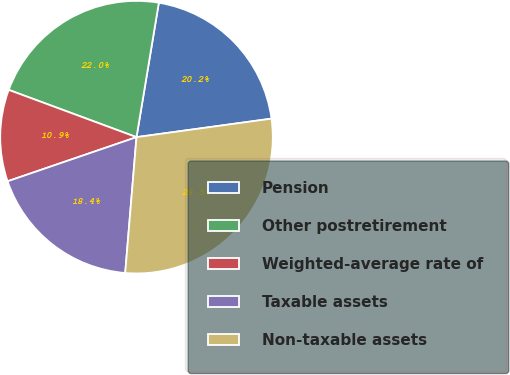Convert chart to OTSL. <chart><loc_0><loc_0><loc_500><loc_500><pie_chart><fcel>Pension<fcel>Other postretirement<fcel>Weighted-average rate of<fcel>Taxable assets<fcel>Non-taxable assets<nl><fcel>20.21%<fcel>21.98%<fcel>10.89%<fcel>18.43%<fcel>28.49%<nl></chart> 